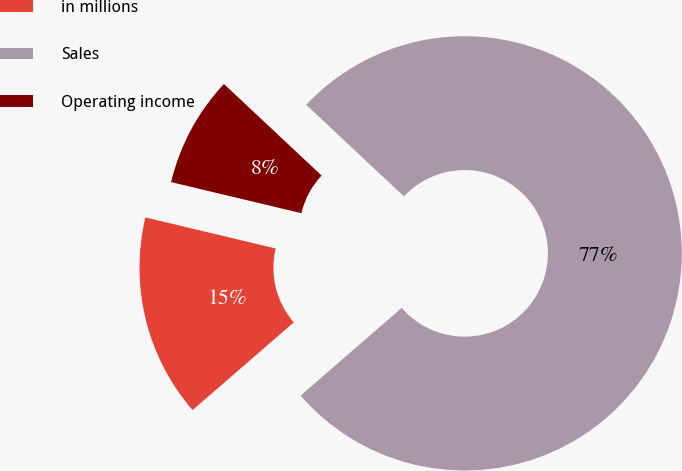Convert chart to OTSL. <chart><loc_0><loc_0><loc_500><loc_500><pie_chart><fcel>in millions<fcel>Sales<fcel>Operating income<nl><fcel>15.1%<fcel>76.65%<fcel>8.26%<nl></chart> 